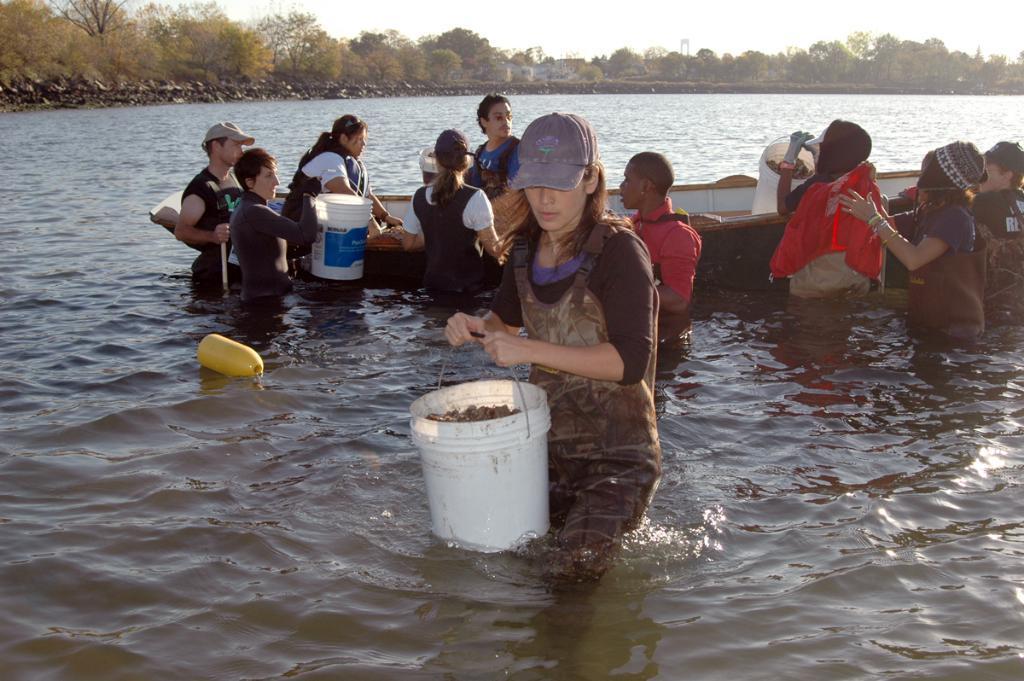Describe this image in one or two sentences. In this image we can see a woman wearing the cap and holding the bucket. We can also see a man and a woman in the boat which is on the surface of the river. We can also see a few people with some objects in the background. We can see the trees and also the sky. 